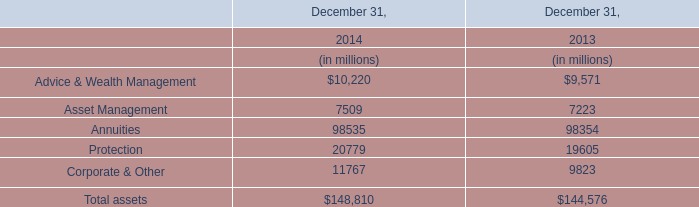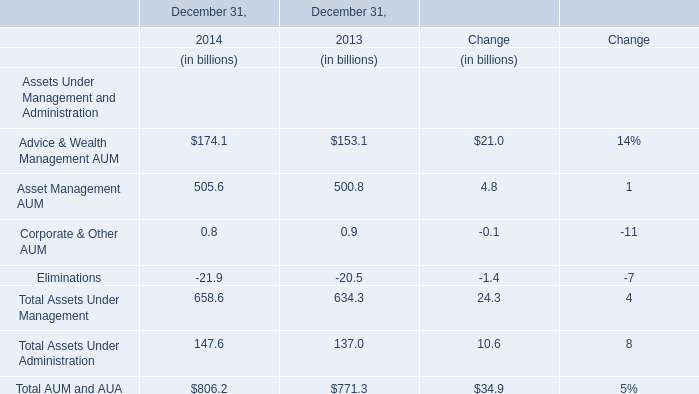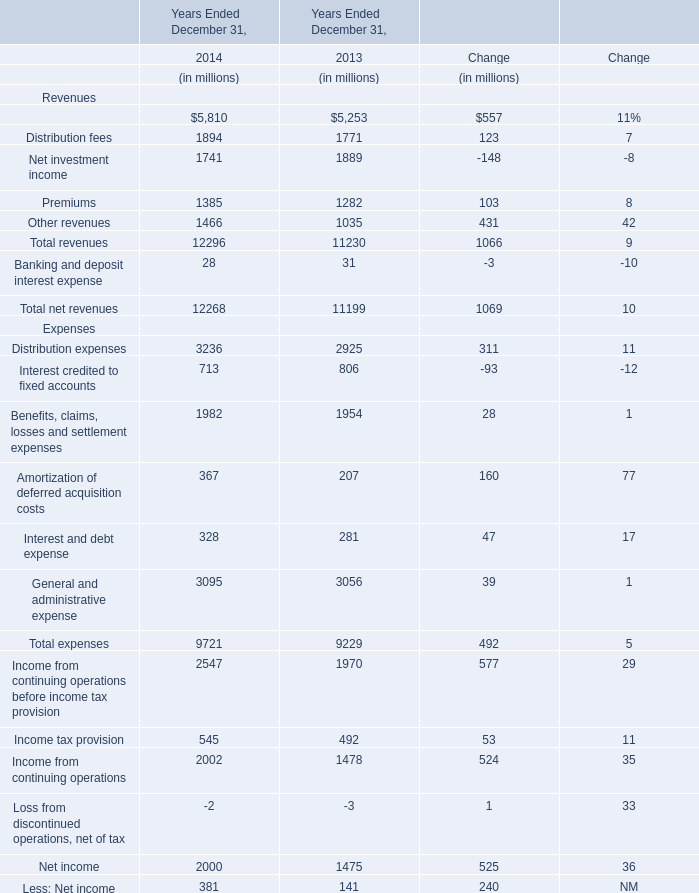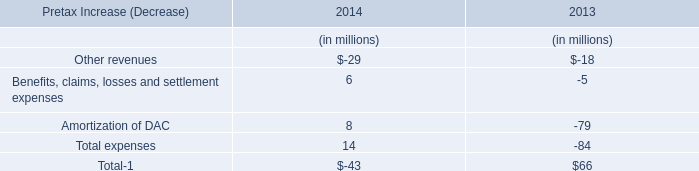If Premiums develops with the same growth rate in 2014, what will it reach in 2015? (in dollars in millions) 
Computations: (1385 * (1 + (8 / 100)))
Answer: 1495.8. 